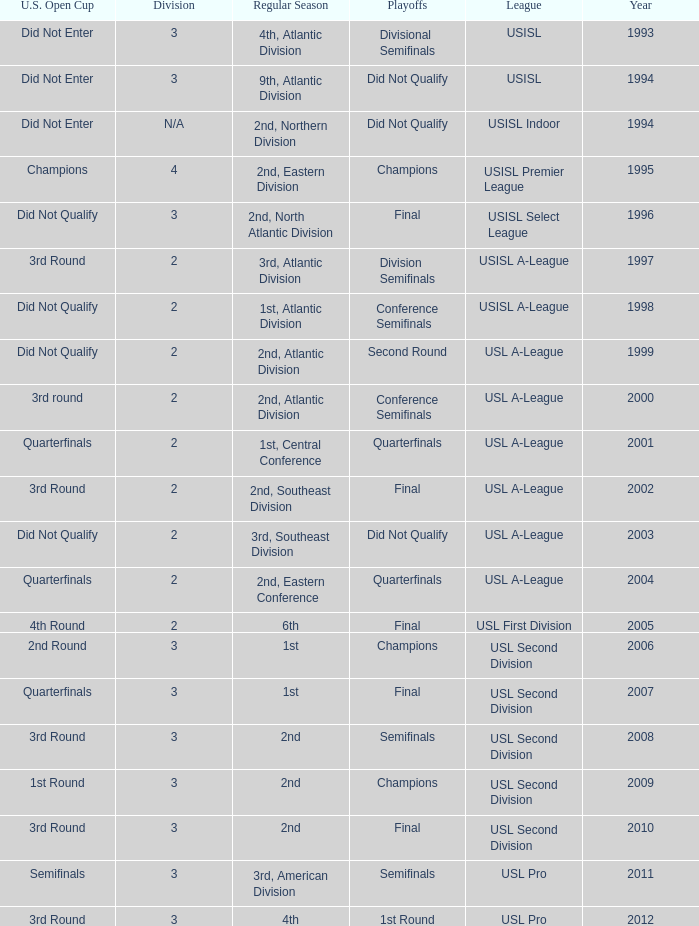What's the u.s. open cup status for regular season of 4th, atlantic division  Did Not Enter. 